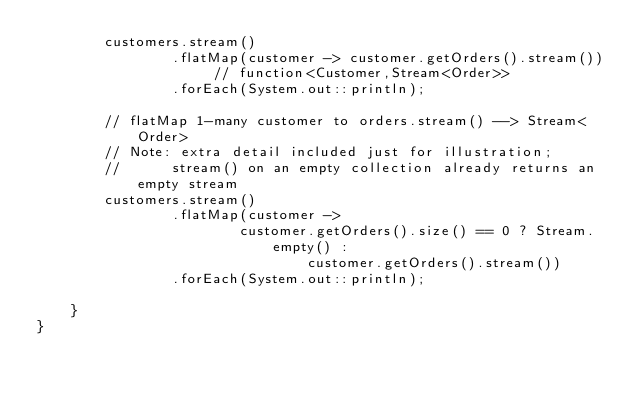Convert code to text. <code><loc_0><loc_0><loc_500><loc_500><_Java_>        customers.stream()
                .flatMap(customer -> customer.getOrders().stream()) // function<Customer,Stream<Order>>
                .forEach(System.out::println);

        // flatMap 1-many customer to orders.stream() --> Stream<Order>
        // Note: extra detail included just for illustration;
        //      stream() on an empty collection already returns an empty stream
        customers.stream()
                .flatMap(customer ->
                        customer.getOrders().size() == 0 ? Stream.empty() :
                                customer.getOrders().stream())
                .forEach(System.out::println);

    }
}
</code> 